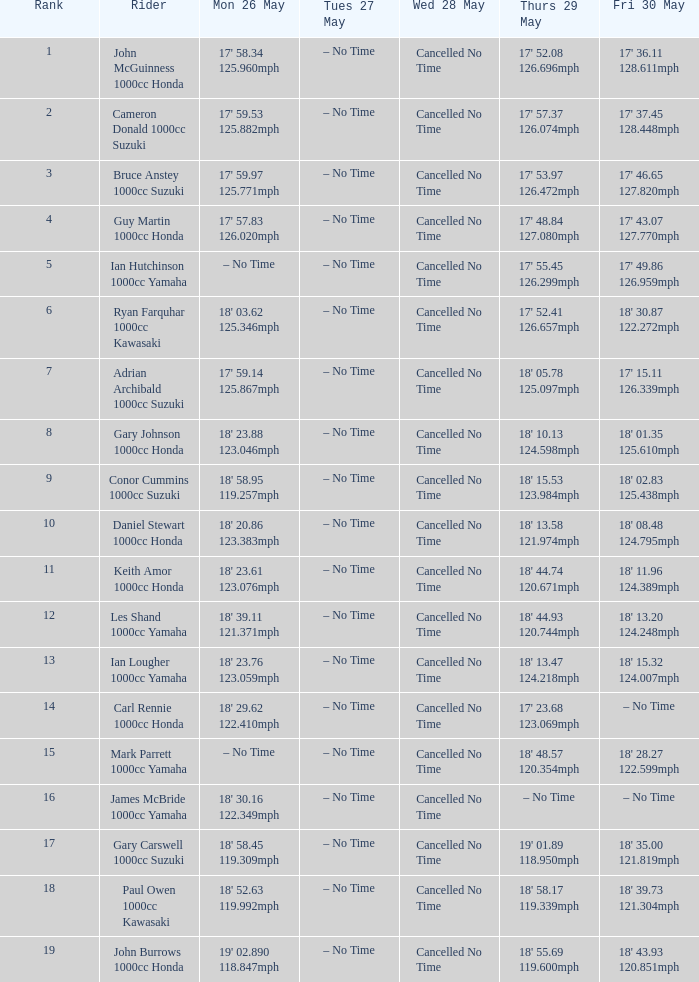890 11 18' 43.93 120.851mph. 